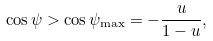Convert formula to latex. <formula><loc_0><loc_0><loc_500><loc_500>\cos { \psi } > \cos { \psi _ { \max } } = - \frac { u } { 1 - u } ,</formula> 